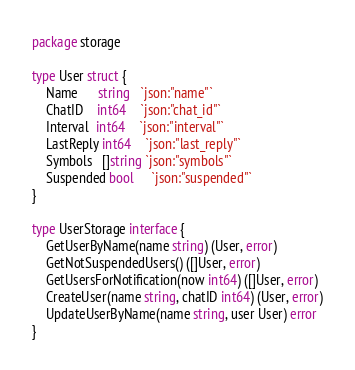<code> <loc_0><loc_0><loc_500><loc_500><_Go_>package storage

type User struct {
	Name      string   `json:"name"`
	ChatID    int64    `json:"chat_id"`
	Interval  int64    `json:"interval"`
	LastReply int64    `json:"last_reply"`
	Symbols   []string `json:"symbols"`
	Suspended bool     `json:"suspended"`
}

type UserStorage interface {
	GetUserByName(name string) (User, error)
	GetNotSuspendedUsers() ([]User, error)
	GetUsersForNotification(now int64) ([]User, error)
	CreateUser(name string, chatID int64) (User, error)
	UpdateUserByName(name string, user User) error
}
</code> 